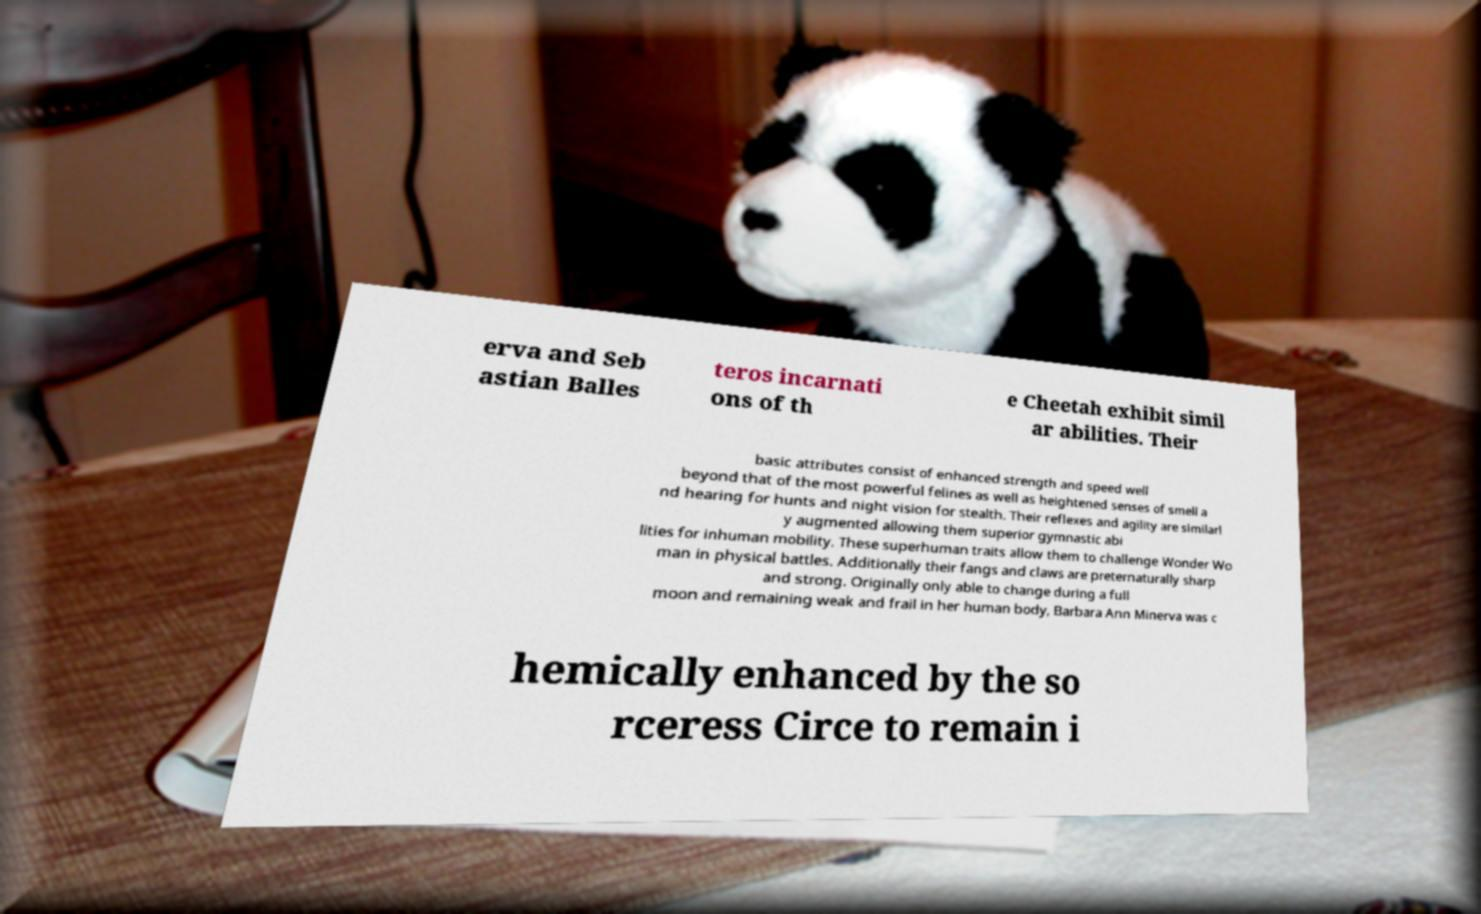Please identify and transcribe the text found in this image. erva and Seb astian Balles teros incarnati ons of th e Cheetah exhibit simil ar abilities. Their basic attributes consist of enhanced strength and speed well beyond that of the most powerful felines as well as heightened senses of smell a nd hearing for hunts and night vision for stealth. Their reflexes and agility are similarl y augmented allowing them superior gymnastic abi lities for inhuman mobility. These superhuman traits allow them to challenge Wonder Wo man in physical battles. Additionally their fangs and claws are preternaturally sharp and strong. Originally only able to change during a full moon and remaining weak and frail in her human body, Barbara Ann Minerva was c hemically enhanced by the so rceress Circe to remain i 